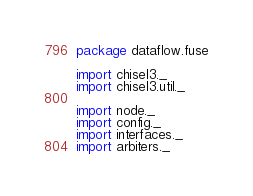<code> <loc_0><loc_0><loc_500><loc_500><_Scala_>package dataflow.fuse

import chisel3._
import chisel3.util._

import node._
import config._
import interfaces._
import arbiters._</code> 